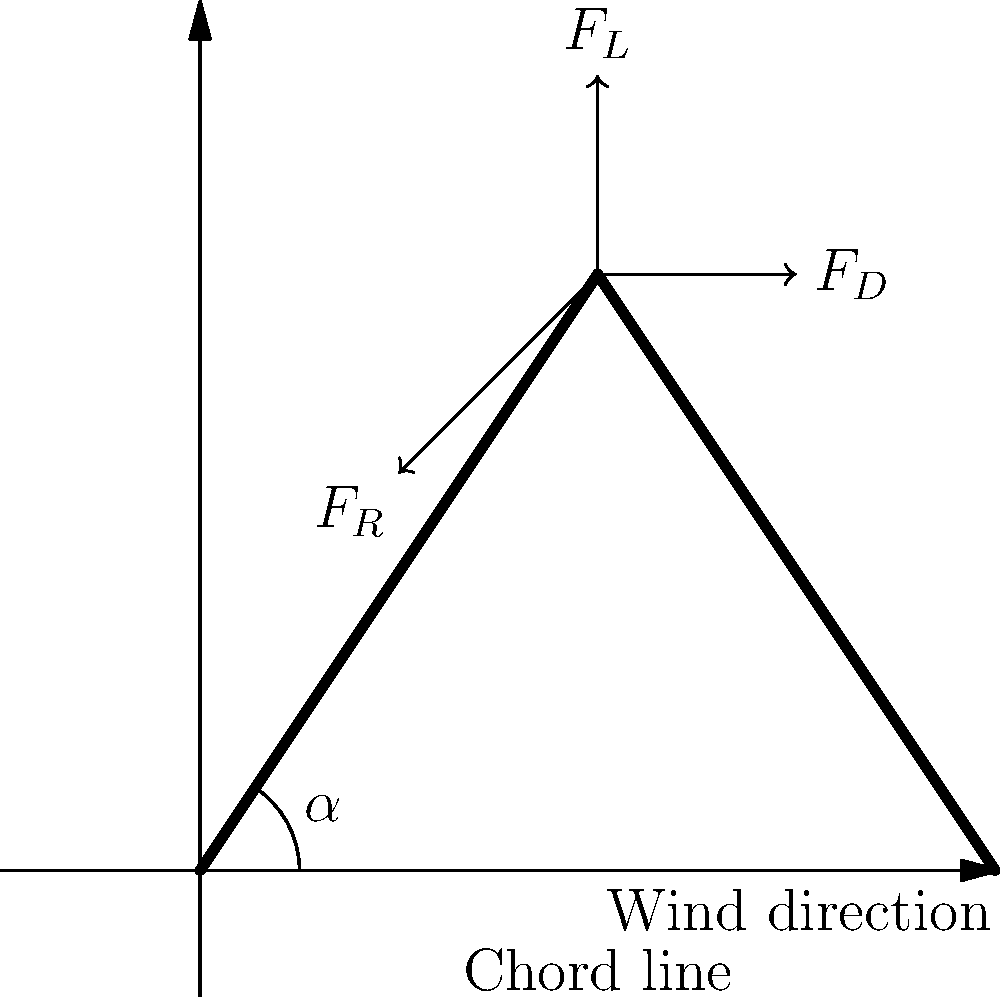In the force diagram of a wind turbine blade shown above, identify the three primary forces acting on the blade and explain how the angle of attack ($\alpha$) affects the blade's performance in terms of sustainability and energy generation. To answer this question, let's break it down step-by-step:

1. Identifying the three primary forces:
   a) $F_L$: Lift force - perpendicular to the wind direction
   b) $F_D$: Drag force - parallel to the wind direction
   c) $F_R$: Resultant force - the vector sum of lift and drag forces

2. The angle of attack ($\alpha$) is the angle between the chord line of the blade and the relative wind direction.

3. Effect of angle of attack on blade performance:
   a) As $\alpha$ increases (within a certain range):
      - Lift force ($F_L$) increases
      - Drag force ($F_D$) also increases, but at a slower rate initially
   b) Optimal angle of attack:
      - Maximizes the lift-to-drag ratio ($F_L/F_D$)
      - Typically between 5° and 15° for most wind turbine blades

4. Sustainability and energy generation:
   a) Higher lift-to-drag ratio means more efficient energy extraction from the wind
   b) Optimal angle of attack leads to:
      - Increased power output
      - Reduced wear on turbine components
      - Longer lifespan of the turbine
   c) Variable pitch systems can adjust the angle of attack to optimize performance in different wind conditions

5. Trade-offs:
   a) Too low angle of attack: Insufficient lift, reduced power generation
   b) Too high angle of attack: Increased drag, potential stall, reduced efficiency

By understanding and optimizing the angle of attack, wind turbine designers can create more efficient and sustainable energy systems, contributing to cleaner energy production and reduced environmental impact.
Answer: The three primary forces are lift ($F_L$), drag ($F_D$), and resultant ($F_R$). The angle of attack ($\alpha$) affects blade performance by influencing the lift-to-drag ratio, with an optimal angle (typically 5°-15°) maximizing efficiency and sustainability. 